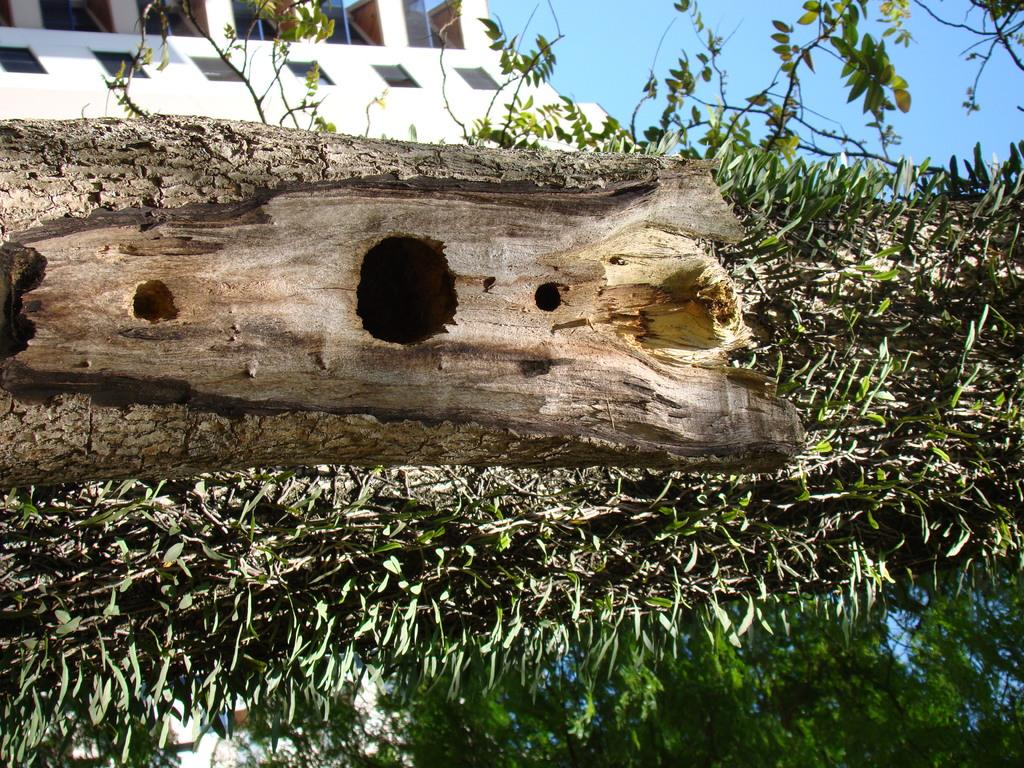What is the main object in the image? There is a wooden log in the image. Are there any other objects or living organisms near the wooden log? Yes, there are plants around the wooden log. What can be seen in the background of the image? There is a building in the background of the image. What type of appliance can be seen near the wooden log? There is no appliance present near the wooden log in the image. How many pigs are visible in the image? There are no pigs visible in the image. 